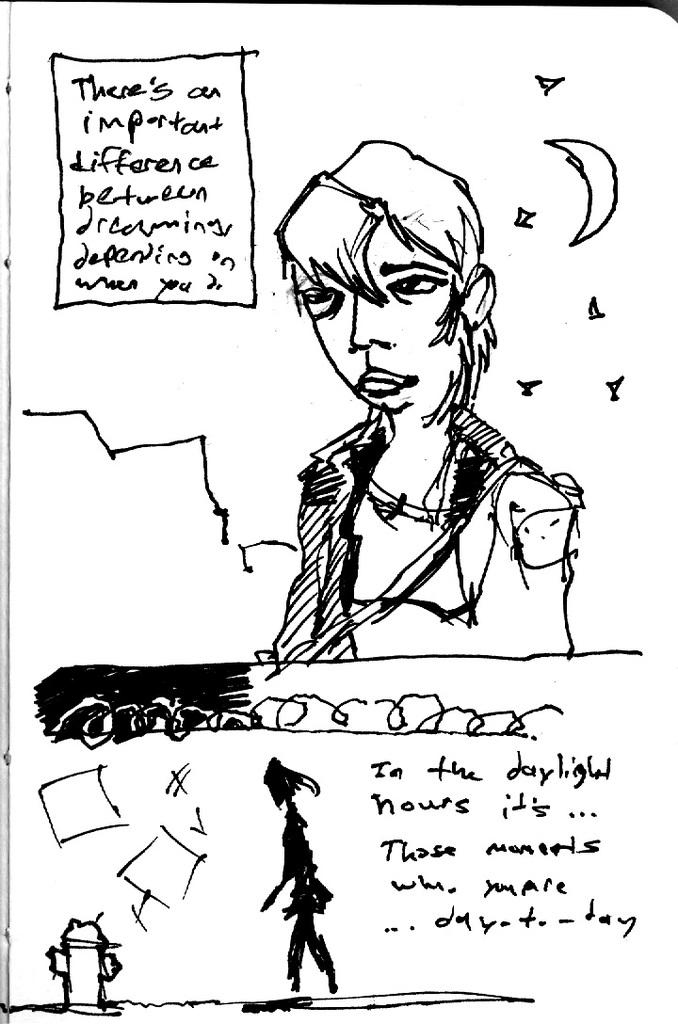What type of drawings can be seen on the paper in the image? There are drawings of people, a fire hydrant, and the moon on the paper. What else is present on the paper besides the drawings? There is writing on the paper. What sign is the son holding in the image? There is no son or sign present in the image; it only features drawings on a paper. 